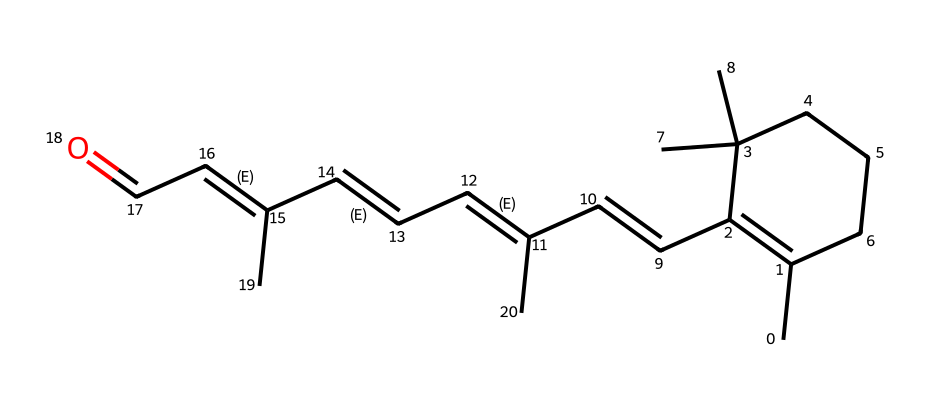What is the main functional group present in retinal? The chemical structure contains a carbonyl group (C=O), which identifies it as an aldehyde. The presence of the carbonyl at one end of the carbon chain informs us that this compound is indeed an aldehyde.
Answer: aldehyde How many rings are present in this structure of retinal? By analyzing the structure, it can be observed that there is one cyclic portion indicated by the CC1...C1 notation, which refers to a ring structure. Thus, there is one ring in retinal.
Answer: one What are the geometric isomers present in retinal's double bonds? The structure contains multiple double bonds with specific arrangements; the presence of cis and trans configurations relates to the geometrical isomerism observed around these double bonds. The cis and trans designations indicate the relative positioning of substituents around the double bonds.
Answer: cis and trans How many carbon atoms are present in retinal? By examining the SMILES representation closely, we can count all the carbon (C) atoms. There are a total of 20 carbon atoms indicated in the structure.
Answer: 20 What effect does the cis-trans isomerism in retinal have on vision? The ability of retinal to undergo isomerization affects its interaction with light, which is crucial for vision. The conversion between cis and trans forms allows the molecule to trigger a biological response when exposed to photons, leading to visual signaling.
Answer: affects visual signaling 